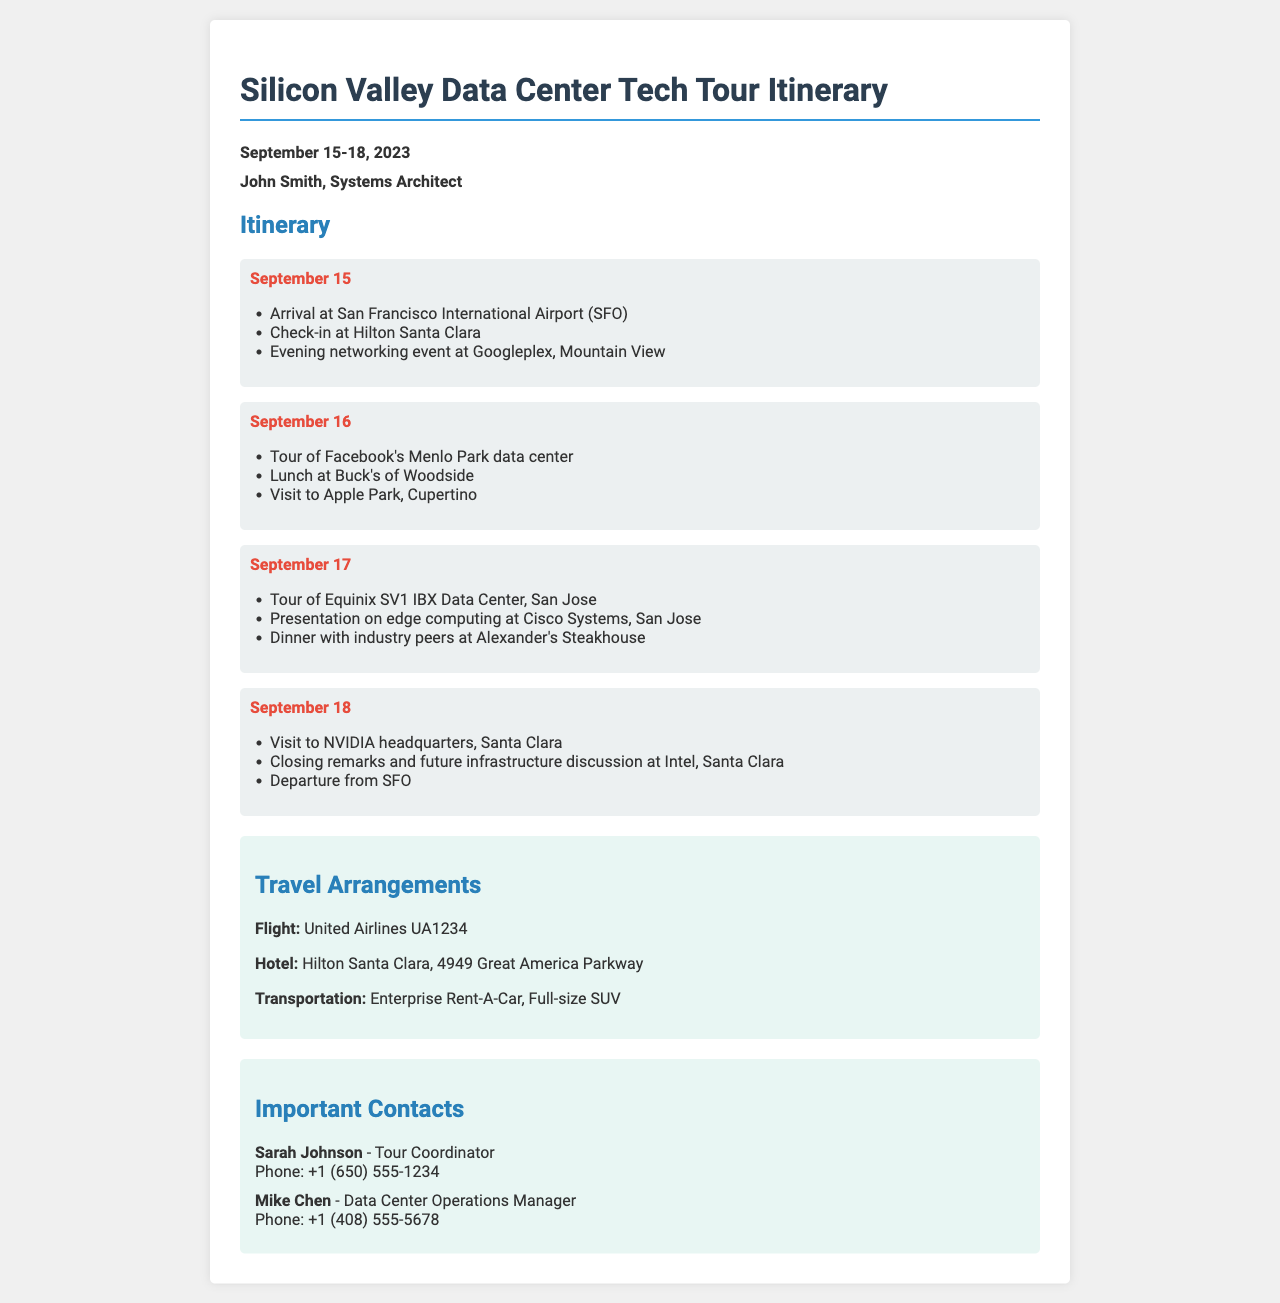What are the dates of the tech tour? The dates of the tech tour are clearly mentioned in the document as September 15-18, 2023.
Answer: September 15-18, 2023 Who is the traveler listed in the document? The traveler is named at the start of the document as John Smith.
Answer: John Smith Which hotel will the traveler check into? The hotel name is specified in the travel arrangements section as Hilton Santa Clara.
Answer: Hilton Santa Clara What is the phone number of the tour coordinator? The phone number for the contact Sarah Johnson is included in the contacts section, listed as +1 (650) 555-1234.
Answer: +1 (650) 555-1234 What activity is scheduled for September 17? The activities for September 17 involve the tour of Equinix SV1 IBX Data Center and a presentation at Cisco Systems, which both highlight the day's agenda.
Answer: Tour of Equinix SV1 IBX Data Center How is transportation arranged for the tour? The travel arrangements mention the form of transportation as a full-size SUV from Enterprise Rent-A-Car, summarizing the transportation details.
Answer: Full-size SUV Which data center is visited on September 16? The document clearly states that the tour on September 16 includes Facebook's Menlo Park data center.
Answer: Facebook's Menlo Park data center What is the concluding event of the tech tour? The document specifies that the closing remarks and future infrastructure discussion will be held at Intel, marking the conclusion of the tour.
Answer: Closing remarks and future infrastructure discussion at Intel 